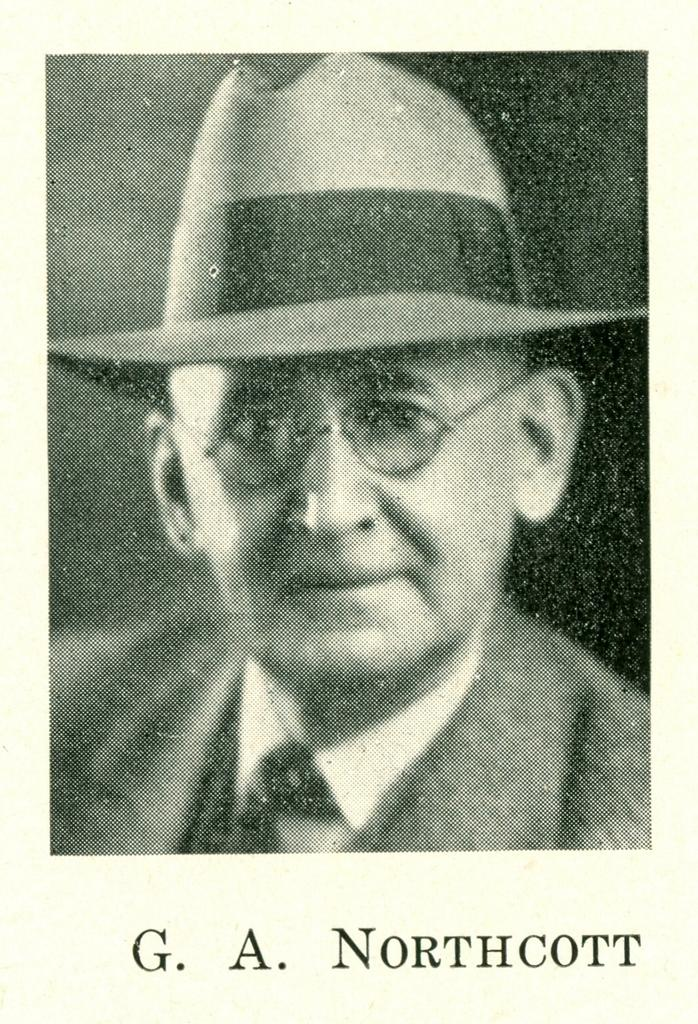What is the main subject of the image? There is a photograph in the image. Who or what is featured in the photograph? The photograph includes one person. Is there any text associated with the photograph? Yes, there is written text at the bottom of the photograph. How many bricks are visible in the image? There are no bricks present in the image; it features a photograph with a person and written text. What type of change is being made in the image? There is no indication of any change being made in the image, as it primarily consists of a photograph with a person and written text. 